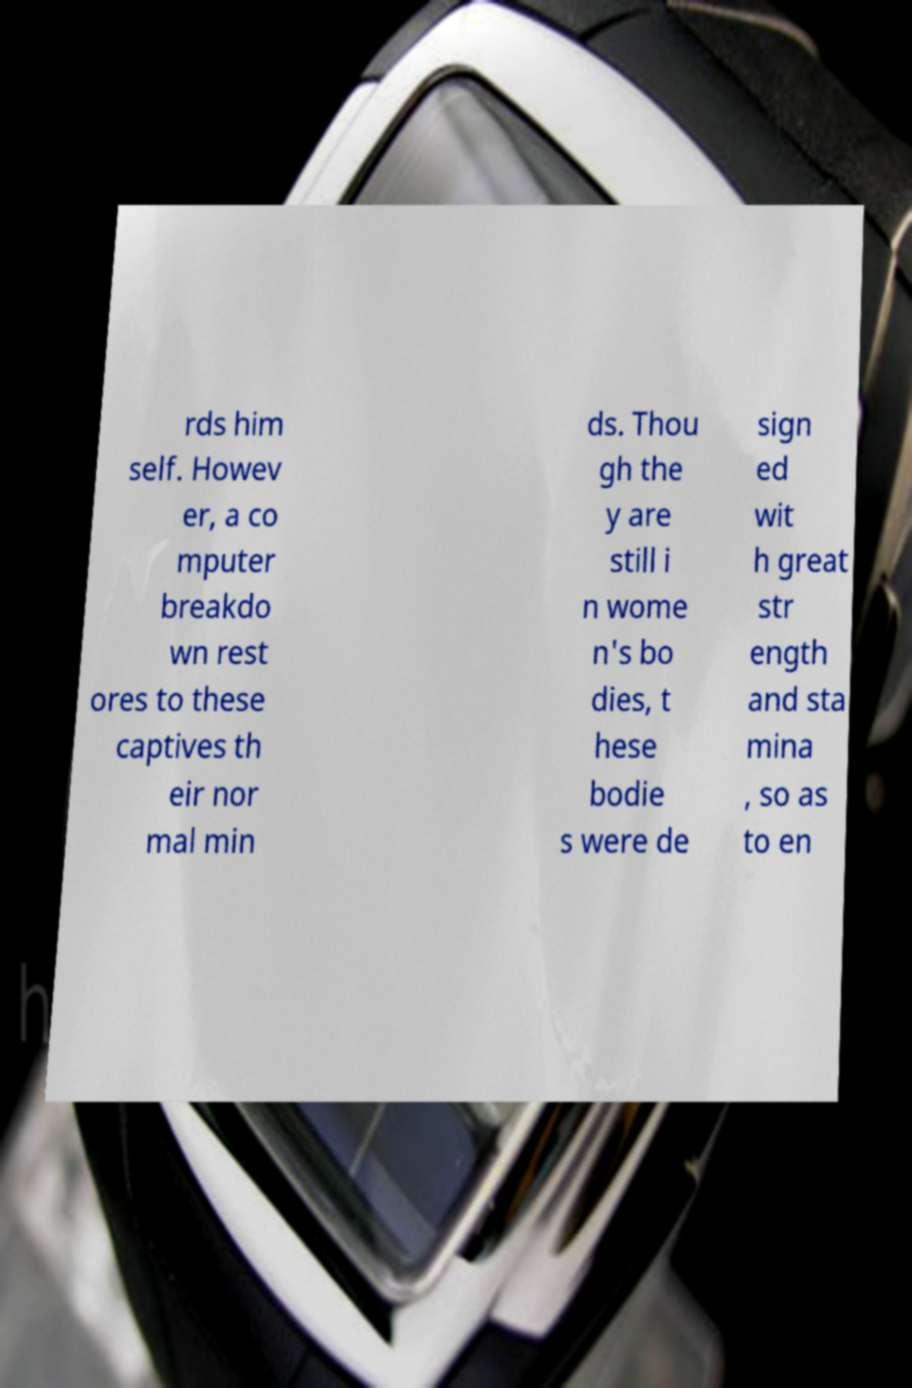Could you extract and type out the text from this image? rds him self. Howev er, a co mputer breakdo wn rest ores to these captives th eir nor mal min ds. Thou gh the y are still i n wome n's bo dies, t hese bodie s were de sign ed wit h great str ength and sta mina , so as to en 